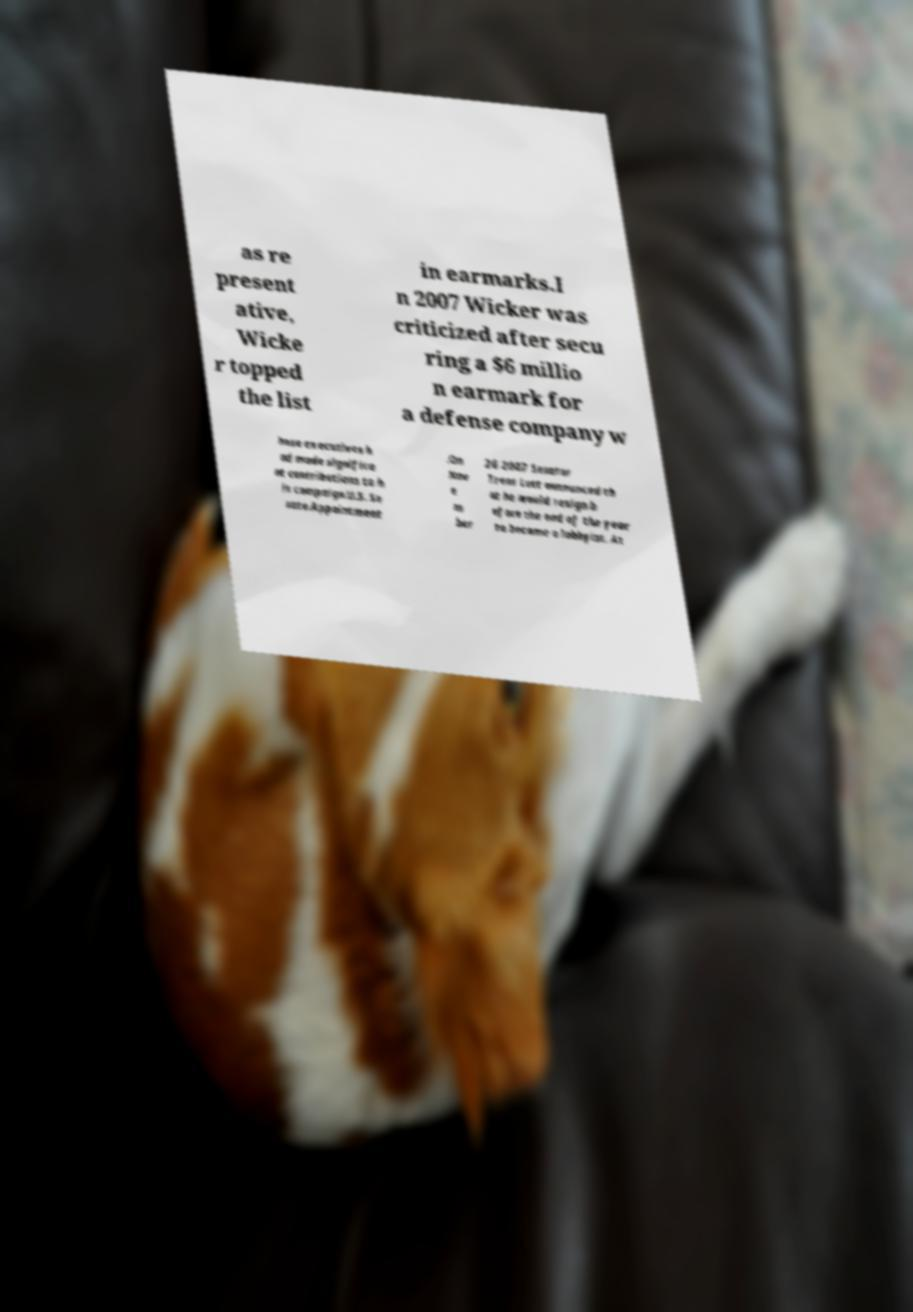Please read and relay the text visible in this image. What does it say? as re present ative, Wicke r topped the list in earmarks.I n 2007 Wicker was criticized after secu ring a $6 millio n earmark for a defense company w hose executives h ad made significa nt contributions to h is campaign.U.S. Se nate.Appointment .On Nov e m ber 26 2007 Senator Trent Lott announced th at he would resign b efore the end of the year to become a lobbyist. At 